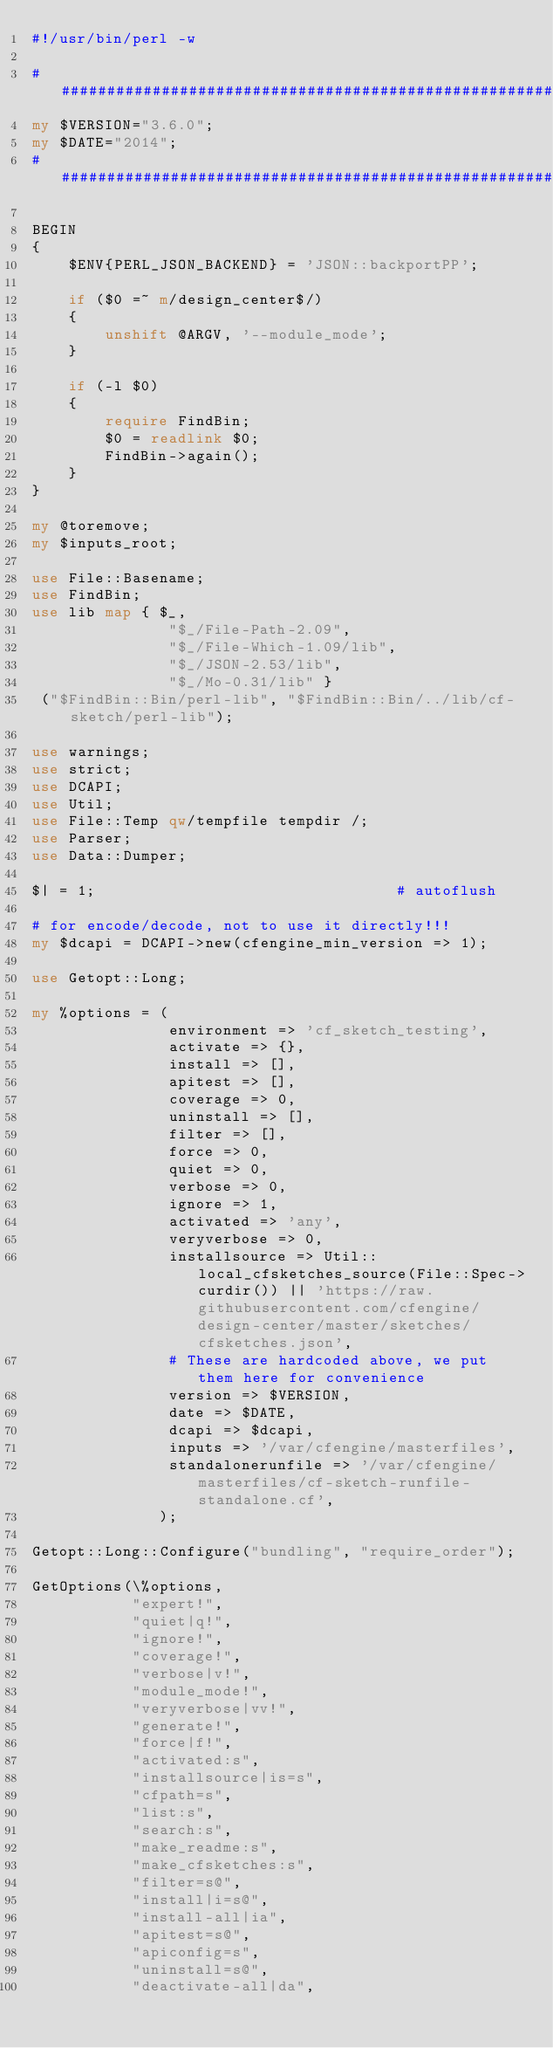<code> <loc_0><loc_0><loc_500><loc_500><_Perl_>#!/usr/bin/perl -w

######################################################################
my $VERSION="3.6.0";
my $DATE="2014";
######################################################################

BEGIN
{
    $ENV{PERL_JSON_BACKEND} = 'JSON::backportPP';

    if ($0 =~ m/design_center$/)
    {
        unshift @ARGV, '--module_mode';
    }

    if (-l $0)
    {
        require FindBin;
        $0 = readlink $0;
        FindBin->again();
    }
}

my @toremove;
my $inputs_root;

use File::Basename;
use FindBin;
use lib map { $_,
               "$_/File-Path-2.09",
               "$_/File-Which-1.09/lib",
               "$_/JSON-2.53/lib",
               "$_/Mo-0.31/lib" }
 ("$FindBin::Bin/perl-lib", "$FindBin::Bin/../lib/cf-sketch/perl-lib");

use warnings;
use strict;
use DCAPI;
use Util;
use File::Temp qw/tempfile tempdir /;
use Parser;
use Data::Dumper;

$| = 1;                                 # autoflush

# for encode/decode, not to use it directly!!!
my $dcapi = DCAPI->new(cfengine_min_version => 1);

use Getopt::Long;

my %options = (
               environment => 'cf_sketch_testing',
               activate => {},
               install => [],
               apitest => [],
               coverage => 0,
               uninstall => [],
               filter => [],
               force => 0,
               quiet => 0,
               verbose => 0,
               ignore => 1,
               activated => 'any',
               veryverbose => 0,
               installsource => Util::local_cfsketches_source(File::Spec->curdir()) || 'https://raw.githubusercontent.com/cfengine/design-center/master/sketches/cfsketches.json',
               # These are hardcoded above, we put them here for convenience
               version => $VERSION,
               date => $DATE,
               dcapi => $dcapi,
               inputs => '/var/cfengine/masterfiles',
               standalonerunfile => '/var/cfengine/masterfiles/cf-sketch-runfile-standalone.cf',
              );

Getopt::Long::Configure("bundling", "require_order");

GetOptions(\%options,
           "expert!",
           "quiet|q!",
           "ignore!",
           "coverage!",
           "verbose|v!",
           "module_mode!",
           "veryverbose|vv!",
           "generate!",
           "force|f!",
           "activated:s",
           "installsource|is=s",
           "cfpath=s",
           "list:s",
           "search:s",
           "make_readme:s",
           "make_cfsketches:s",
           "filter=s@",
           "install|i=s@",
           "install-all|ia",
           "apitest=s@",
           "apiconfig=s",
           "uninstall=s@",
           "deactivate-all|da",</code> 